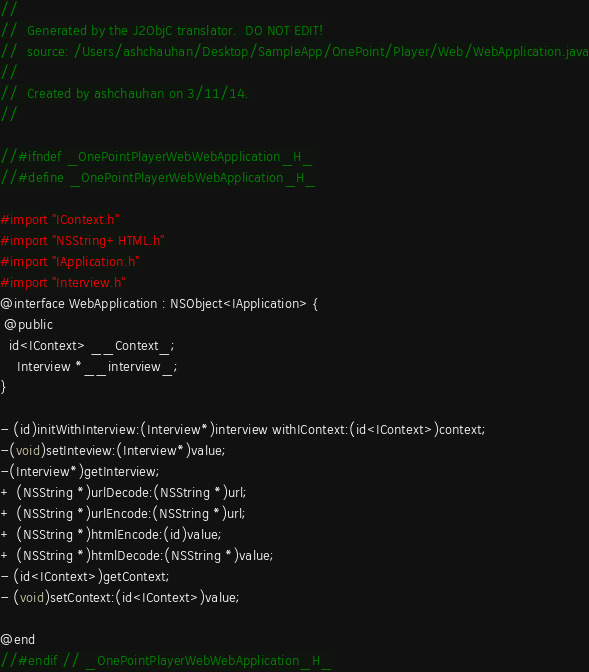Convert code to text. <code><loc_0><loc_0><loc_500><loc_500><_C_>//
//  Generated by the J2ObjC translator.  DO NOT EDIT!
//  source: /Users/ashchauhan/Desktop/SampleApp/OnePoint/Player/Web/WebApplication.java
//
//  Created by ashchauhan on 3/11/14.
//

//#ifndef _OnePointPlayerWebWebApplication_H_
//#define _OnePointPlayerWebWebApplication_H_

#import "IContext.h"
#import "NSString+HTML.h"
#import "IApplication.h"
#import "Interview.h"
@interface WebApplication : NSObject<IApplication> {
 @public
  id<IContext> __Context_;
    Interview *__interview_;
}

- (id)initWithInterview:(Interview*)interview withIContext:(id<IContext>)context;
-(void)setInteview:(Interview*)value;
-(Interview*)getInterview;
+ (NSString *)urlDecode:(NSString *)url;
+ (NSString *)urlEncode:(NSString *)url;
+ (NSString *)htmlEncode:(id)value;
+ (NSString *)htmlDecode:(NSString *)value;
- (id<IContext>)getContext;
- (void)setContext:(id<IContext>)value;

@end
//#endif // _OnePointPlayerWebWebApplication_H_
</code> 